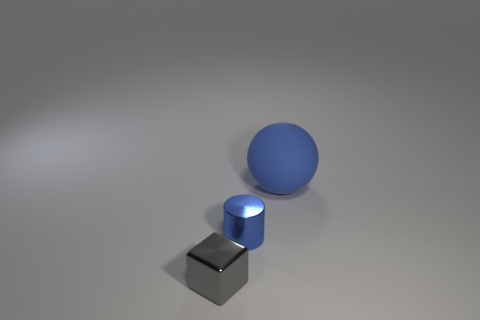Add 2 large balls. How many objects exist? 5 Subtract all cubes. How many objects are left? 2 Subtract 0 green cubes. How many objects are left? 3 Subtract all large blue rubber objects. Subtract all big red cylinders. How many objects are left? 2 Add 3 tiny blue metallic objects. How many tiny blue metallic objects are left? 4 Add 1 tiny metal things. How many tiny metal things exist? 3 